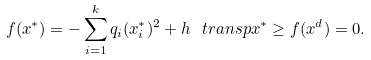Convert formula to latex. <formula><loc_0><loc_0><loc_500><loc_500>f ( x ^ { * } ) = - \sum _ { i = 1 } ^ { k } q _ { i } ( x ^ { * } _ { i } ) ^ { 2 } + h ^ { \ } t r a n s p x ^ { * } \geq f ( x ^ { d } ) = 0 .</formula> 